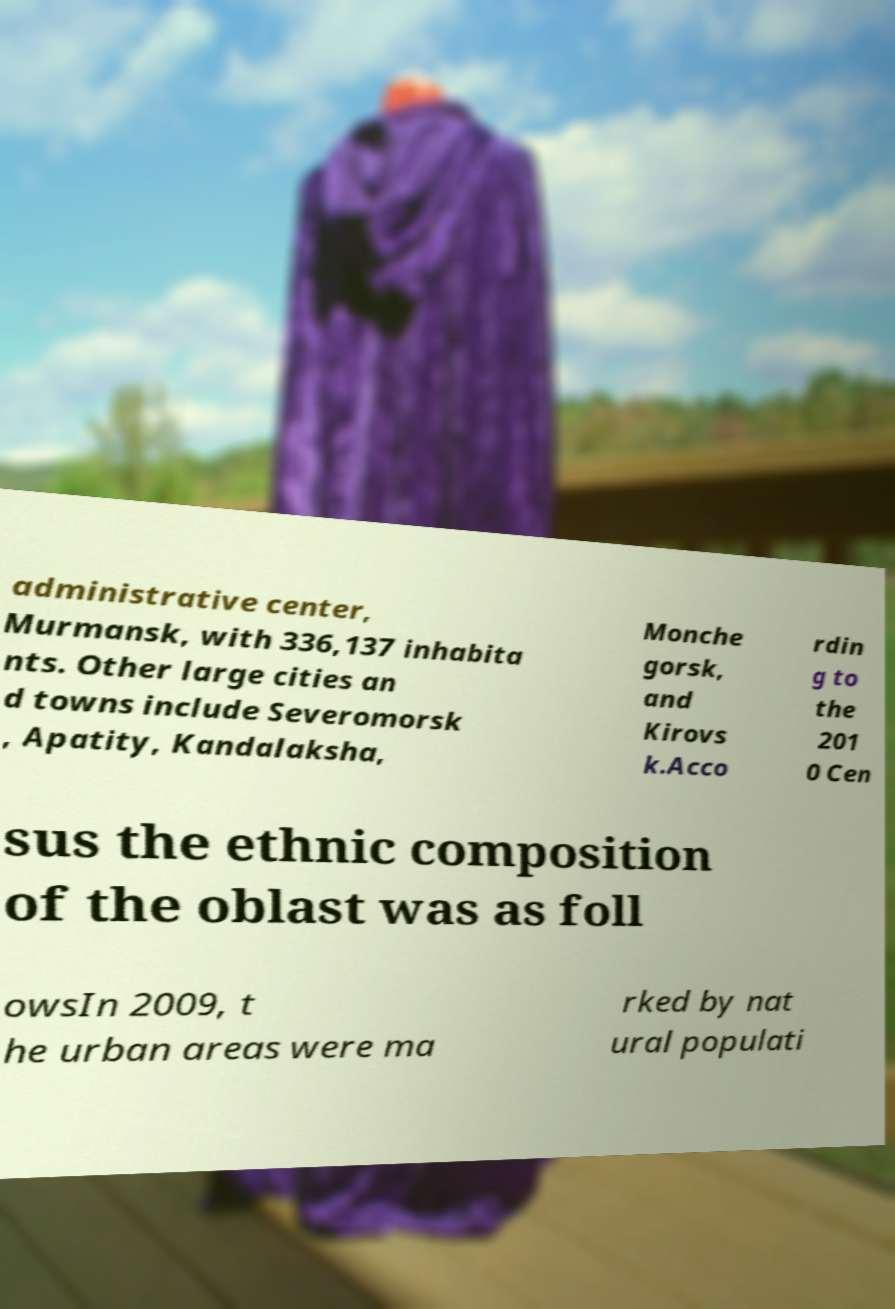Could you extract and type out the text from this image? administrative center, Murmansk, with 336,137 inhabita nts. Other large cities an d towns include Severomorsk , Apatity, Kandalaksha, Monche gorsk, and Kirovs k.Acco rdin g to the 201 0 Cen sus the ethnic composition of the oblast was as foll owsIn 2009, t he urban areas were ma rked by nat ural populati 